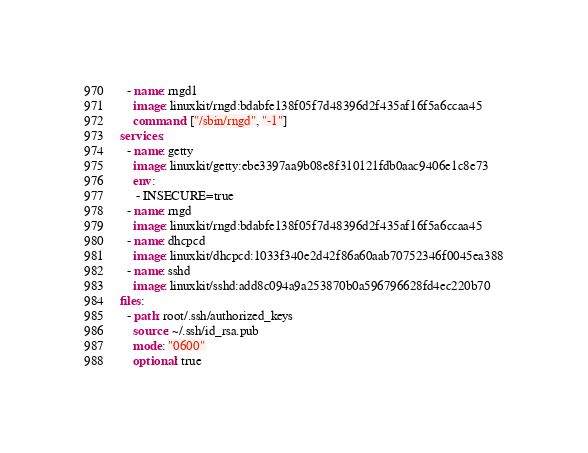Convert code to text. <code><loc_0><loc_0><loc_500><loc_500><_YAML_>  - name: rngd1
    image: linuxkit/rngd:bdabfe138f05f7d48396d2f435af16f5a6ccaa45
    command: ["/sbin/rngd", "-1"]
services:
  - name: getty
    image: linuxkit/getty:ebe3397aa9b08e8f310121fdb0aac9406e1c8e73
    env:
     - INSECURE=true
  - name: rngd
    image: linuxkit/rngd:bdabfe138f05f7d48396d2f435af16f5a6ccaa45
  - name: dhcpcd
    image: linuxkit/dhcpcd:1033f340e2d42f86a60aab70752346f0045ea388
  - name: sshd
    image: linuxkit/sshd:add8c094a9a253870b0a596796628fd4ec220b70
files:
  - path: root/.ssh/authorized_keys
    source: ~/.ssh/id_rsa.pub
    mode: "0600"
    optional: true
</code> 